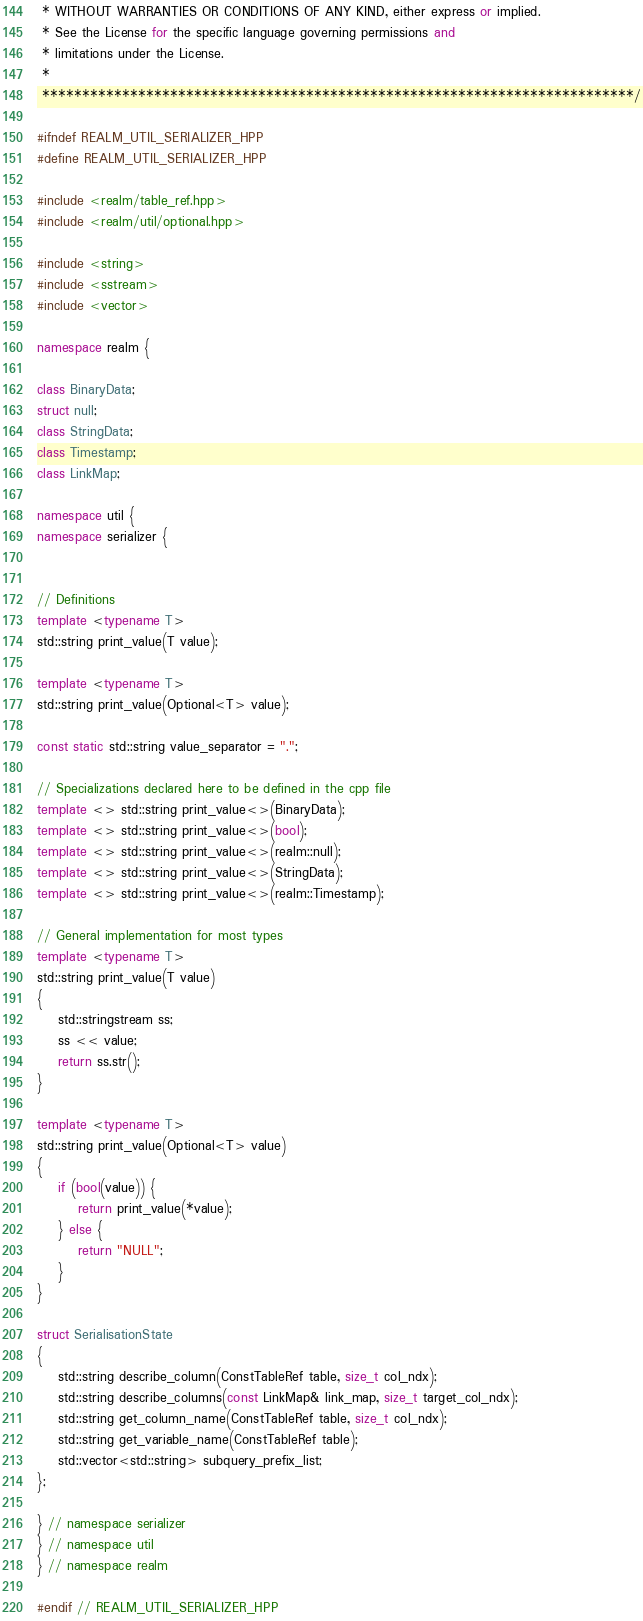Convert code to text. <code><loc_0><loc_0><loc_500><loc_500><_C++_> * WITHOUT WARRANTIES OR CONDITIONS OF ANY KIND, either express or implied.
 * See the License for the specific language governing permissions and
 * limitations under the License.
 *
 **************************************************************************/

#ifndef REALM_UTIL_SERIALIZER_HPP
#define REALM_UTIL_SERIALIZER_HPP

#include <realm/table_ref.hpp>
#include <realm/util/optional.hpp>

#include <string>
#include <sstream>
#include <vector>

namespace realm {

class BinaryData;
struct null;
class StringData;
class Timestamp;
class LinkMap;

namespace util {
namespace serializer {


// Definitions
template <typename T>
std::string print_value(T value);

template <typename T>
std::string print_value(Optional<T> value);

const static std::string value_separator = ".";

// Specializations declared here to be defined in the cpp file
template <> std::string print_value<>(BinaryData);
template <> std::string print_value<>(bool);
template <> std::string print_value<>(realm::null);
template <> std::string print_value<>(StringData);
template <> std::string print_value<>(realm::Timestamp);

// General implementation for most types
template <typename T>
std::string print_value(T value)
{
    std::stringstream ss;
    ss << value;
    return ss.str();
}

template <typename T>
std::string print_value(Optional<T> value)
{
    if (bool(value)) {
        return print_value(*value);
    } else {
        return "NULL";
    }
}

struct SerialisationState
{
    std::string describe_column(ConstTableRef table, size_t col_ndx);
    std::string describe_columns(const LinkMap& link_map, size_t target_col_ndx);
    std::string get_column_name(ConstTableRef table, size_t col_ndx);
    std::string get_variable_name(ConstTableRef table);
    std::vector<std::string> subquery_prefix_list;
};

} // namespace serializer
} // namespace util
} // namespace realm

#endif // REALM_UTIL_SERIALIZER_HPP
</code> 